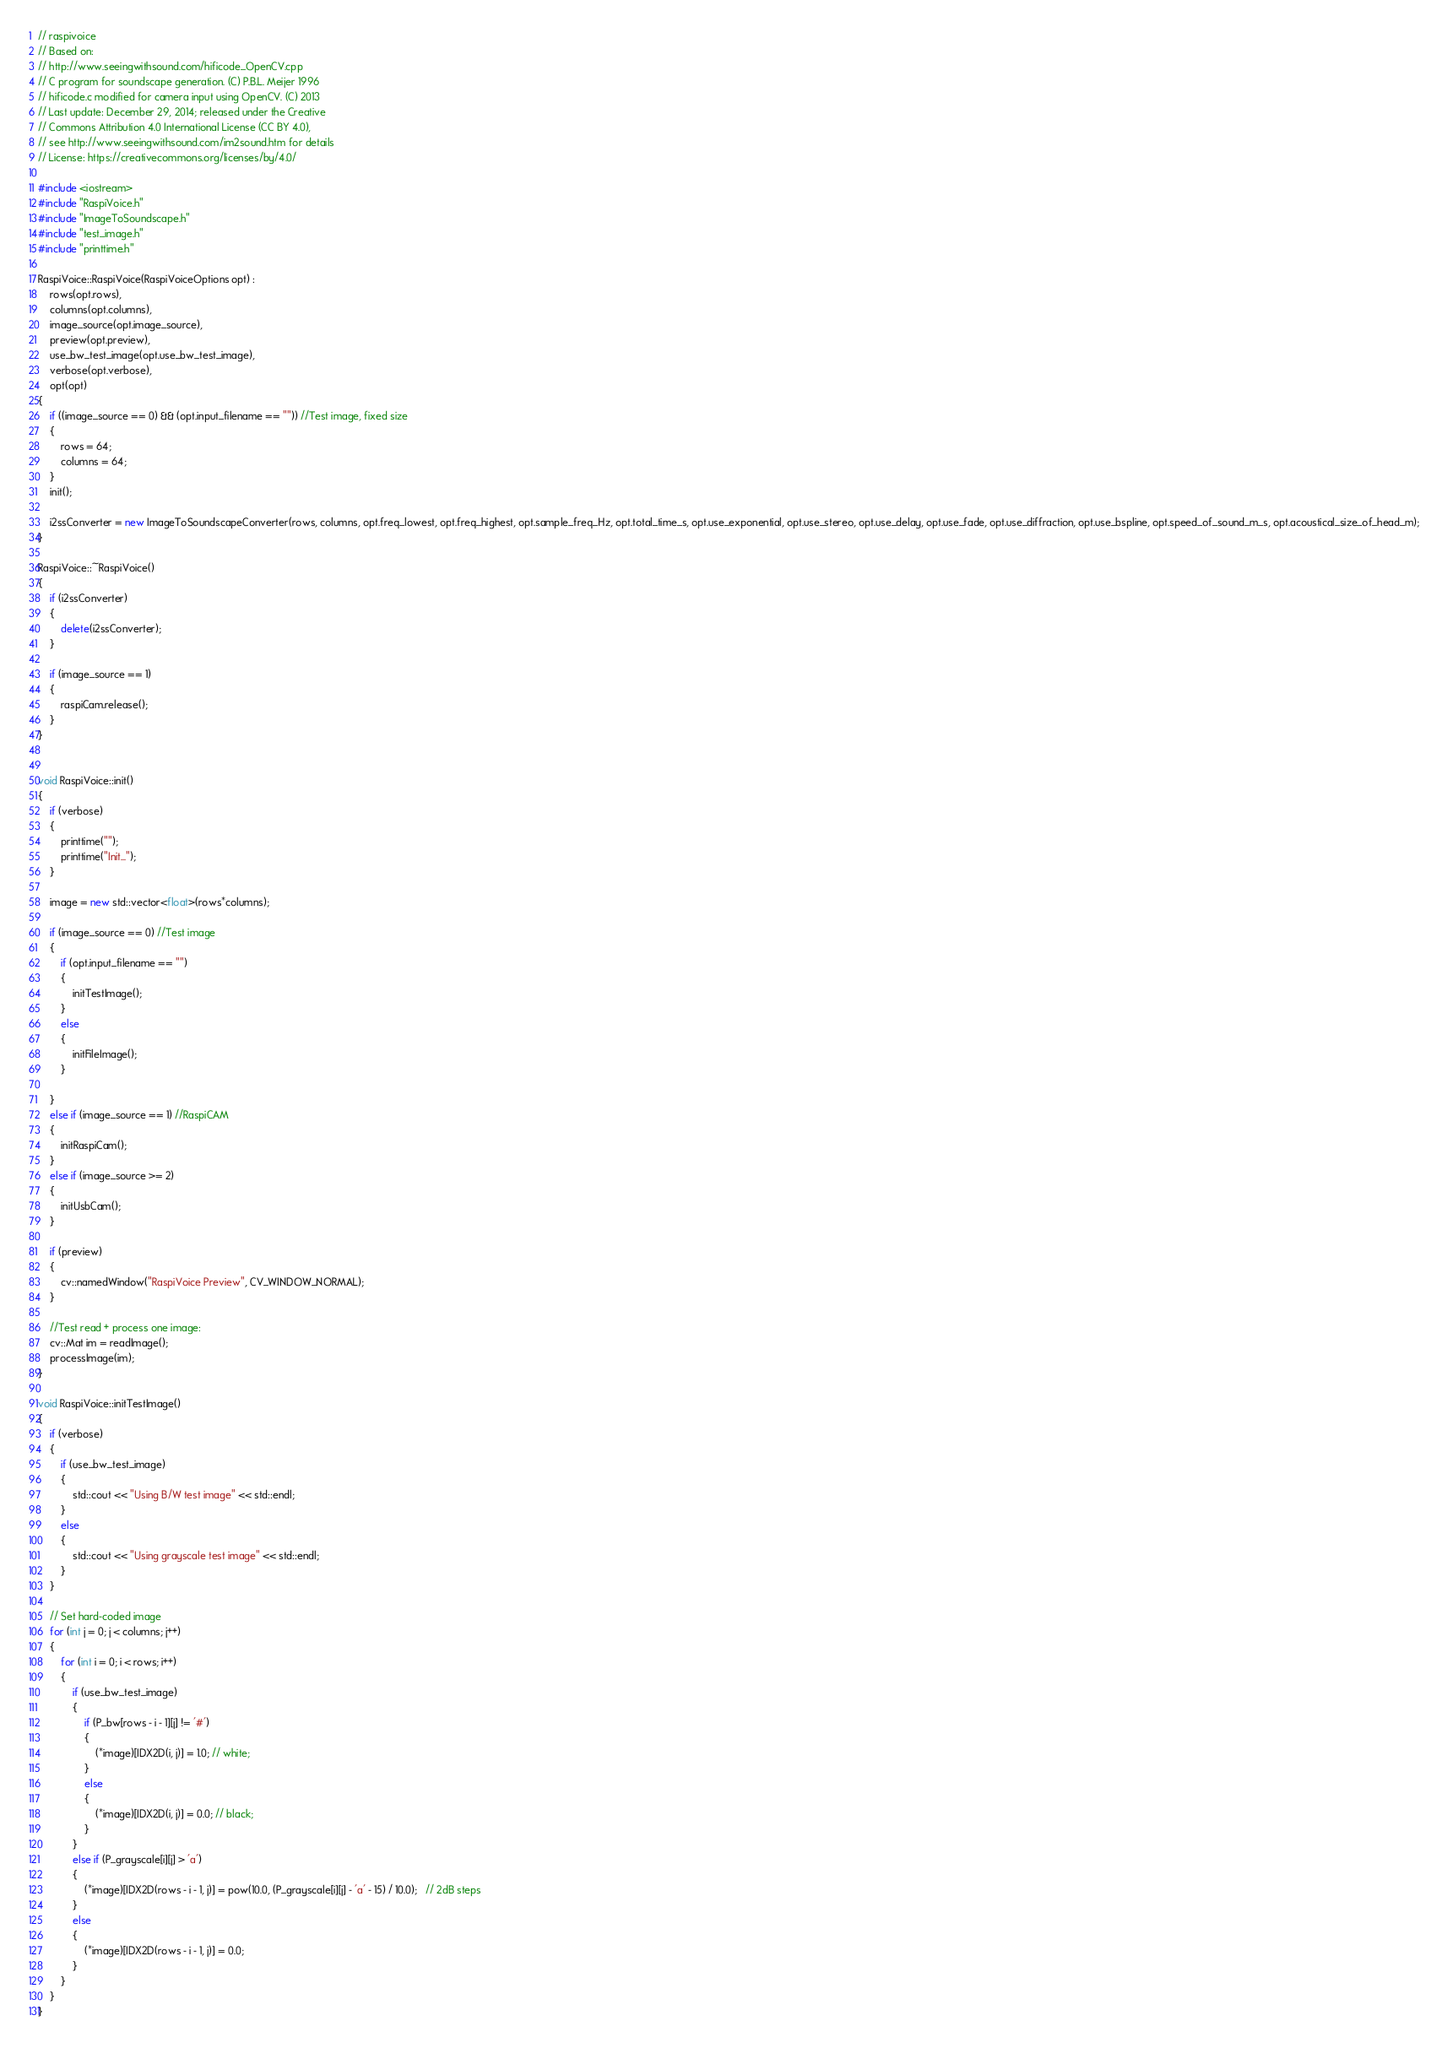Convert code to text. <code><loc_0><loc_0><loc_500><loc_500><_C++_>// raspivoice
// Based on:
// http://www.seeingwithsound.com/hificode_OpenCV.cpp
// C program for soundscape generation. (C) P.B.L. Meijer 1996
// hificode.c modified for camera input using OpenCV. (C) 2013
// Last update: December 29, 2014; released under the Creative
// Commons Attribution 4.0 International License (CC BY 4.0),
// see http://www.seeingwithsound.com/im2sound.htm for details
// License: https://creativecommons.org/licenses/by/4.0/

#include <iostream>
#include "RaspiVoice.h"
#include "ImageToSoundscape.h"
#include "test_image.h"
#include "printtime.h"

RaspiVoice::RaspiVoice(RaspiVoiceOptions opt) :
	rows(opt.rows),
	columns(opt.columns),
	image_source(opt.image_source),
	preview(opt.preview),
	use_bw_test_image(opt.use_bw_test_image),
	verbose(opt.verbose),
	opt(opt)
{
	if ((image_source == 0) && (opt.input_filename == "")) //Test image, fixed size
	{
		rows = 64;
		columns = 64;
	}
	init();

	i2ssConverter = new ImageToSoundscapeConverter(rows, columns, opt.freq_lowest, opt.freq_highest, opt.sample_freq_Hz, opt.total_time_s, opt.use_exponential, opt.use_stereo, opt.use_delay, opt.use_fade, opt.use_diffraction, opt.use_bspline, opt.speed_of_sound_m_s, opt.acoustical_size_of_head_m);
}

RaspiVoice::~RaspiVoice()
{
	if (i2ssConverter)
	{
		delete(i2ssConverter);
	}

	if (image_source == 1)
	{
		raspiCam.release();
	}
}


void RaspiVoice::init()
{
	if (verbose)
	{
		printtime("");
		printtime("Init...");
	}

	image = new std::vector<float>(rows*columns);

	if (image_source == 0) //Test image
	{
		if (opt.input_filename == "")
		{
			initTestImage();
		}
		else
		{
			initFileImage();
		}
		
	}
	else if (image_source == 1) //RaspiCAM
	{
		initRaspiCam();
	}
	else if (image_source >= 2)
	{
		initUsbCam();
	}

	if (preview)
	{
		cv::namedWindow("RaspiVoice Preview", CV_WINDOW_NORMAL);
	}

	//Test read + process one image:
	cv::Mat im = readImage();
	processImage(im);
}

void RaspiVoice::initTestImage()
{
	if (verbose)
	{
		if (use_bw_test_image)
		{
			std::cout << "Using B/W test image" << std::endl;
		}
		else
		{
			std::cout << "Using grayscale test image" << std::endl;
		}
	}

	// Set hard-coded image
	for (int j = 0; j < columns; j++)
	{
		for (int i = 0; i < rows; i++)
		{
			if (use_bw_test_image)
			{
				if (P_bw[rows - i - 1][j] != '#')
				{
					(*image)[IDX2D(i, j)] = 1.0; // white;
				}
				else
				{
					(*image)[IDX2D(i, j)] = 0.0; // black;
				}
			}
			else if (P_grayscale[i][j] > 'a')
			{
				(*image)[IDX2D(rows - i - 1, j)] = pow(10.0, (P_grayscale[i][j] - 'a' - 15) / 10.0);   // 2dB steps
			}
			else
			{
				(*image)[IDX2D(rows - i - 1, j)] = 0.0;
			}
		}
	}
}
</code> 